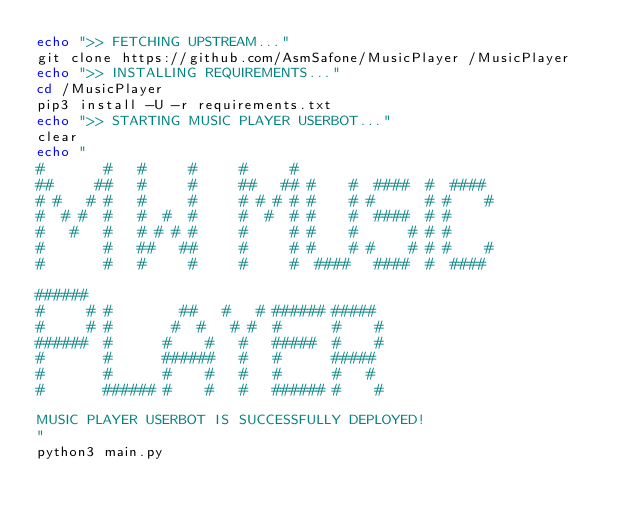<code> <loc_0><loc_0><loc_500><loc_500><_Bash_>echo ">> FETCHING UPSTREAM..."
git clone https://github.com/AsmSafone/MusicPlayer /MusicPlayer
echo ">> INSTALLING REQUIREMENTS..."
cd /MusicPlayer
pip3 install -U -r requirements.txt
echo ">> STARTING MUSIC PLAYER USERBOT..."
clear
echo "
#       #   #     #     #     #                        
##     ##   #     #     ##   ## #    #  ####  #  ####  
# #   # #   #     #     # # # # #    # #      # #    # 
#  # #  #   #  #  #     #  #  # #    #  ####  # #      
#   #   #   # # # #     #     # #    #      # # #      
#       #   ##   ##     #     # #    # #    # # #    #   
#       #   #     #     #     #  ####   ####  #  ####  
                               
######                                    
#     # #        ##   #   # ###### #####  
#     # #       #  #   # #  #      #    # 
######  #      #    #   #   #####  #    # 
#       #      ######   #   #      #####  
#       #      #    #   #   #      #   #  
#       ###### #    #   #   ###### #    # 
                                          
MUSIC PLAYER USERBOT IS SUCCESSFULLY DEPLOYED!
"
python3 main.py
</code> 